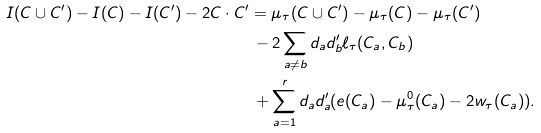Convert formula to latex. <formula><loc_0><loc_0><loc_500><loc_500>I ( C \cup C ^ { \prime } ) - I ( C ) - I ( C ^ { \prime } ) - 2 C \cdot C ^ { \prime } & = \mu _ { \tau } ( C \cup C ^ { \prime } ) - \mu _ { \tau } ( C ) - \mu _ { \tau } ( C ^ { \prime } ) \\ & \, - 2 \sum _ { a \neq b } d _ { a } d _ { b } ^ { \prime } \ell _ { \tau } ( C _ { a } , C _ { b } ) \\ & \, + \sum _ { a = 1 } ^ { r } d _ { a } d _ { a } ^ { \prime } ( e ( C _ { a } ) - \mu _ { \tau } ^ { 0 } ( C _ { a } ) - 2 w _ { \tau } ( C _ { a } ) ) .</formula> 